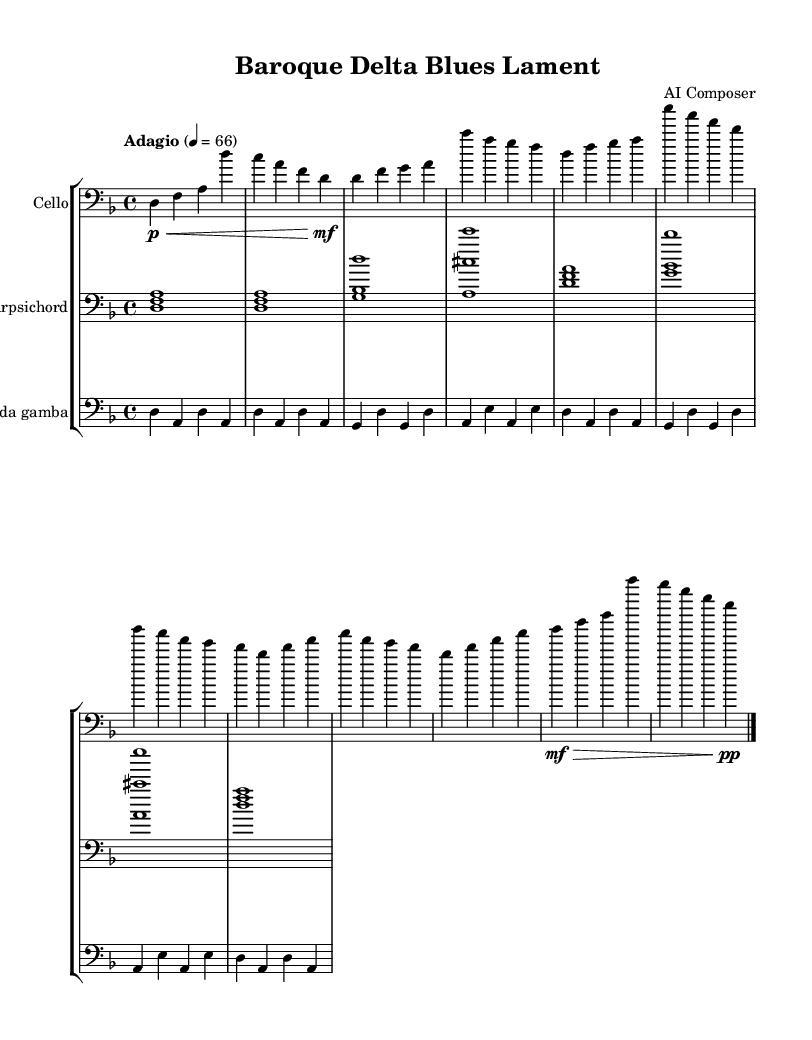What is the key signature of this music? The key signature indicates that the piece is written in D minor, which consists of one flat (B flat). This can be observed at the beginning of the staff, where the flat sign indicates the key.
Answer: D minor What is the time signature of this piece? The time signature is found at the start and is marked as 4/4, meaning there are four beats in each measure and the quarter note gets one beat.
Answer: 4/4 What is the tempo marking given for this composition? The tempo marking is listed as "Adagio" with a metronome marking of 66, suggesting this piece should be played slowly and expressively at a speed of 66 beats per minute. This is typically found above the staff at the beginning of the piece.
Answer: Adagio 4 = 66 How many measures are in the cello part? To determine this, we look through the cello part notation. The cello section contains 8 measures, each separated by a bar line, allowing us to count the measures clearly.
Answer: 8 What type of music is this composition inspired by? The piece is described as fusing Baroque techniques with Delta blues scales. This is indicated in the title and throughout the musical style presented in the score, which combines elements from both genres.
Answer: Blues-inspired chamber music What is the dynamic marking at the end of the cello part? The dynamic marking at the end is pp (pianissimo), indicating that the final section of the music should be played very softly. This can be seen in the last measure of the cello part.
Answer: pp Which instrument plays the simplest harmonic part throughout the piece? Upon examining the score, the harpsichord plays a simplified harmonic background consistently, offering rhythmic support without intricate melodic lines, making it the most straightforward part in comparsing to others.
Answer: Harpsichord 